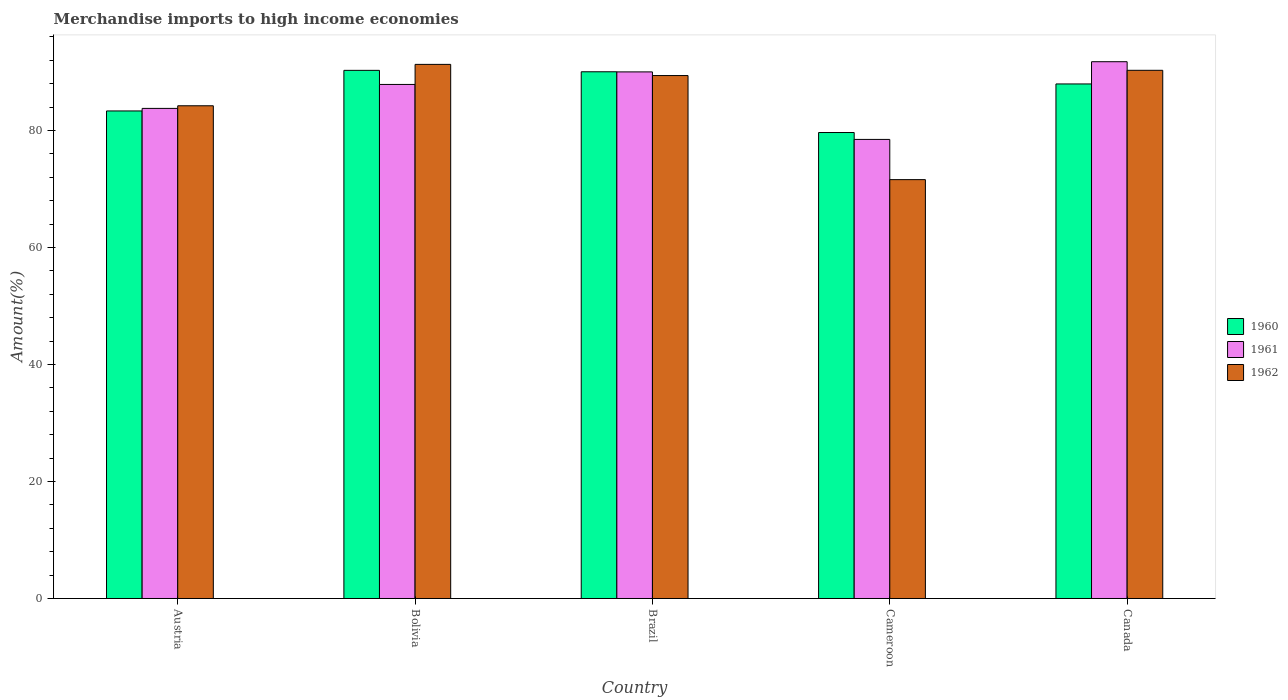How many different coloured bars are there?
Make the answer very short. 3. Are the number of bars per tick equal to the number of legend labels?
Provide a short and direct response. Yes. Are the number of bars on each tick of the X-axis equal?
Your answer should be compact. Yes. In how many cases, is the number of bars for a given country not equal to the number of legend labels?
Ensure brevity in your answer.  0. What is the percentage of amount earned from merchandise imports in 1961 in Bolivia?
Your answer should be very brief. 87.89. Across all countries, what is the maximum percentage of amount earned from merchandise imports in 1962?
Ensure brevity in your answer.  91.32. Across all countries, what is the minimum percentage of amount earned from merchandise imports in 1960?
Offer a terse response. 79.67. In which country was the percentage of amount earned from merchandise imports in 1960 minimum?
Give a very brief answer. Cameroon. What is the total percentage of amount earned from merchandise imports in 1961 in the graph?
Offer a terse response. 431.97. What is the difference between the percentage of amount earned from merchandise imports in 1960 in Brazil and that in Canada?
Provide a succinct answer. 2.08. What is the difference between the percentage of amount earned from merchandise imports in 1961 in Bolivia and the percentage of amount earned from merchandise imports in 1960 in Cameroon?
Make the answer very short. 8.22. What is the average percentage of amount earned from merchandise imports in 1960 per country?
Offer a terse response. 86.27. What is the difference between the percentage of amount earned from merchandise imports of/in 1960 and percentage of amount earned from merchandise imports of/in 1962 in Bolivia?
Provide a short and direct response. -1.02. In how many countries, is the percentage of amount earned from merchandise imports in 1962 greater than 12 %?
Offer a terse response. 5. What is the ratio of the percentage of amount earned from merchandise imports in 1960 in Bolivia to that in Canada?
Keep it short and to the point. 1.03. Is the percentage of amount earned from merchandise imports in 1962 in Bolivia less than that in Canada?
Your answer should be compact. No. Is the difference between the percentage of amount earned from merchandise imports in 1960 in Bolivia and Canada greater than the difference between the percentage of amount earned from merchandise imports in 1962 in Bolivia and Canada?
Your answer should be very brief. Yes. What is the difference between the highest and the second highest percentage of amount earned from merchandise imports in 1962?
Provide a succinct answer. -0.9. What is the difference between the highest and the lowest percentage of amount earned from merchandise imports in 1961?
Your answer should be very brief. 13.28. What does the 1st bar from the left in Austria represents?
Your answer should be compact. 1960. How many bars are there?
Offer a very short reply. 15. Are all the bars in the graph horizontal?
Your answer should be compact. No. Are the values on the major ticks of Y-axis written in scientific E-notation?
Provide a short and direct response. No. Does the graph contain any zero values?
Offer a very short reply. No. Where does the legend appear in the graph?
Keep it short and to the point. Center right. What is the title of the graph?
Offer a very short reply. Merchandise imports to high income economies. What is the label or title of the Y-axis?
Provide a succinct answer. Amount(%). What is the Amount(%) of 1960 in Austria?
Give a very brief answer. 83.35. What is the Amount(%) in 1961 in Austria?
Your answer should be compact. 83.79. What is the Amount(%) in 1962 in Austria?
Give a very brief answer. 84.24. What is the Amount(%) in 1960 in Bolivia?
Your answer should be compact. 90.3. What is the Amount(%) in 1961 in Bolivia?
Your response must be concise. 87.89. What is the Amount(%) in 1962 in Bolivia?
Offer a terse response. 91.32. What is the Amount(%) in 1960 in Brazil?
Your response must be concise. 90.05. What is the Amount(%) of 1961 in Brazil?
Provide a succinct answer. 90.03. What is the Amount(%) of 1962 in Brazil?
Keep it short and to the point. 89.41. What is the Amount(%) of 1960 in Cameroon?
Make the answer very short. 79.67. What is the Amount(%) of 1961 in Cameroon?
Offer a very short reply. 78.49. What is the Amount(%) in 1962 in Cameroon?
Keep it short and to the point. 71.61. What is the Amount(%) in 1960 in Canada?
Make the answer very short. 87.97. What is the Amount(%) in 1961 in Canada?
Your answer should be compact. 91.77. What is the Amount(%) in 1962 in Canada?
Offer a terse response. 90.3. Across all countries, what is the maximum Amount(%) in 1960?
Provide a succinct answer. 90.3. Across all countries, what is the maximum Amount(%) in 1961?
Keep it short and to the point. 91.77. Across all countries, what is the maximum Amount(%) of 1962?
Keep it short and to the point. 91.32. Across all countries, what is the minimum Amount(%) in 1960?
Offer a terse response. 79.67. Across all countries, what is the minimum Amount(%) in 1961?
Provide a short and direct response. 78.49. Across all countries, what is the minimum Amount(%) in 1962?
Offer a terse response. 71.61. What is the total Amount(%) in 1960 in the graph?
Give a very brief answer. 431.34. What is the total Amount(%) in 1961 in the graph?
Offer a terse response. 431.97. What is the total Amount(%) of 1962 in the graph?
Your response must be concise. 426.88. What is the difference between the Amount(%) in 1960 in Austria and that in Bolivia?
Provide a short and direct response. -6.94. What is the difference between the Amount(%) of 1961 in Austria and that in Bolivia?
Ensure brevity in your answer.  -4.1. What is the difference between the Amount(%) of 1962 in Austria and that in Bolivia?
Offer a very short reply. -7.08. What is the difference between the Amount(%) of 1960 in Austria and that in Brazil?
Offer a very short reply. -6.7. What is the difference between the Amount(%) of 1961 in Austria and that in Brazil?
Offer a very short reply. -6.24. What is the difference between the Amount(%) of 1962 in Austria and that in Brazil?
Provide a short and direct response. -5.17. What is the difference between the Amount(%) of 1960 in Austria and that in Cameroon?
Offer a terse response. 3.69. What is the difference between the Amount(%) of 1961 in Austria and that in Cameroon?
Give a very brief answer. 5.3. What is the difference between the Amount(%) of 1962 in Austria and that in Cameroon?
Give a very brief answer. 12.63. What is the difference between the Amount(%) in 1960 in Austria and that in Canada?
Offer a terse response. -4.62. What is the difference between the Amount(%) of 1961 in Austria and that in Canada?
Ensure brevity in your answer.  -7.98. What is the difference between the Amount(%) of 1962 in Austria and that in Canada?
Provide a short and direct response. -6.06. What is the difference between the Amount(%) in 1960 in Bolivia and that in Brazil?
Make the answer very short. 0.24. What is the difference between the Amount(%) in 1961 in Bolivia and that in Brazil?
Offer a terse response. -2.14. What is the difference between the Amount(%) of 1962 in Bolivia and that in Brazil?
Your response must be concise. 1.91. What is the difference between the Amount(%) in 1960 in Bolivia and that in Cameroon?
Offer a very short reply. 10.63. What is the difference between the Amount(%) in 1961 in Bolivia and that in Cameroon?
Offer a very short reply. 9.4. What is the difference between the Amount(%) of 1962 in Bolivia and that in Cameroon?
Keep it short and to the point. 19.71. What is the difference between the Amount(%) of 1960 in Bolivia and that in Canada?
Ensure brevity in your answer.  2.32. What is the difference between the Amount(%) in 1961 in Bolivia and that in Canada?
Your answer should be compact. -3.89. What is the difference between the Amount(%) of 1962 in Bolivia and that in Canada?
Give a very brief answer. 1.01. What is the difference between the Amount(%) of 1960 in Brazil and that in Cameroon?
Your response must be concise. 10.38. What is the difference between the Amount(%) of 1961 in Brazil and that in Cameroon?
Your answer should be very brief. 11.54. What is the difference between the Amount(%) in 1962 in Brazil and that in Cameroon?
Offer a terse response. 17.8. What is the difference between the Amount(%) of 1960 in Brazil and that in Canada?
Give a very brief answer. 2.08. What is the difference between the Amount(%) in 1961 in Brazil and that in Canada?
Provide a succinct answer. -1.74. What is the difference between the Amount(%) of 1962 in Brazil and that in Canada?
Your answer should be very brief. -0.9. What is the difference between the Amount(%) of 1960 in Cameroon and that in Canada?
Offer a terse response. -8.31. What is the difference between the Amount(%) in 1961 in Cameroon and that in Canada?
Give a very brief answer. -13.28. What is the difference between the Amount(%) of 1962 in Cameroon and that in Canada?
Provide a succinct answer. -18.69. What is the difference between the Amount(%) in 1960 in Austria and the Amount(%) in 1961 in Bolivia?
Provide a short and direct response. -4.53. What is the difference between the Amount(%) of 1960 in Austria and the Amount(%) of 1962 in Bolivia?
Your response must be concise. -7.96. What is the difference between the Amount(%) of 1961 in Austria and the Amount(%) of 1962 in Bolivia?
Keep it short and to the point. -7.53. What is the difference between the Amount(%) in 1960 in Austria and the Amount(%) in 1961 in Brazil?
Your response must be concise. -6.68. What is the difference between the Amount(%) in 1960 in Austria and the Amount(%) in 1962 in Brazil?
Your answer should be very brief. -6.05. What is the difference between the Amount(%) of 1961 in Austria and the Amount(%) of 1962 in Brazil?
Provide a succinct answer. -5.62. What is the difference between the Amount(%) in 1960 in Austria and the Amount(%) in 1961 in Cameroon?
Offer a terse response. 4.87. What is the difference between the Amount(%) in 1960 in Austria and the Amount(%) in 1962 in Cameroon?
Make the answer very short. 11.74. What is the difference between the Amount(%) of 1961 in Austria and the Amount(%) of 1962 in Cameroon?
Your answer should be very brief. 12.18. What is the difference between the Amount(%) of 1960 in Austria and the Amount(%) of 1961 in Canada?
Your answer should be compact. -8.42. What is the difference between the Amount(%) in 1960 in Austria and the Amount(%) in 1962 in Canada?
Provide a succinct answer. -6.95. What is the difference between the Amount(%) of 1961 in Austria and the Amount(%) of 1962 in Canada?
Offer a very short reply. -6.51. What is the difference between the Amount(%) in 1960 in Bolivia and the Amount(%) in 1961 in Brazil?
Your answer should be very brief. 0.26. What is the difference between the Amount(%) of 1960 in Bolivia and the Amount(%) of 1962 in Brazil?
Your response must be concise. 0.89. What is the difference between the Amount(%) of 1961 in Bolivia and the Amount(%) of 1962 in Brazil?
Keep it short and to the point. -1.52. What is the difference between the Amount(%) of 1960 in Bolivia and the Amount(%) of 1961 in Cameroon?
Make the answer very short. 11.81. What is the difference between the Amount(%) of 1960 in Bolivia and the Amount(%) of 1962 in Cameroon?
Offer a terse response. 18.68. What is the difference between the Amount(%) of 1961 in Bolivia and the Amount(%) of 1962 in Cameroon?
Your response must be concise. 16.28. What is the difference between the Amount(%) in 1960 in Bolivia and the Amount(%) in 1961 in Canada?
Offer a very short reply. -1.48. What is the difference between the Amount(%) in 1960 in Bolivia and the Amount(%) in 1962 in Canada?
Offer a terse response. -0.01. What is the difference between the Amount(%) in 1961 in Bolivia and the Amount(%) in 1962 in Canada?
Provide a succinct answer. -2.42. What is the difference between the Amount(%) in 1960 in Brazil and the Amount(%) in 1961 in Cameroon?
Your answer should be very brief. 11.56. What is the difference between the Amount(%) in 1960 in Brazil and the Amount(%) in 1962 in Cameroon?
Your answer should be very brief. 18.44. What is the difference between the Amount(%) of 1961 in Brazil and the Amount(%) of 1962 in Cameroon?
Ensure brevity in your answer.  18.42. What is the difference between the Amount(%) in 1960 in Brazil and the Amount(%) in 1961 in Canada?
Provide a short and direct response. -1.72. What is the difference between the Amount(%) of 1960 in Brazil and the Amount(%) of 1962 in Canada?
Provide a short and direct response. -0.25. What is the difference between the Amount(%) of 1961 in Brazil and the Amount(%) of 1962 in Canada?
Your answer should be very brief. -0.27. What is the difference between the Amount(%) in 1960 in Cameroon and the Amount(%) in 1961 in Canada?
Provide a short and direct response. -12.11. What is the difference between the Amount(%) in 1960 in Cameroon and the Amount(%) in 1962 in Canada?
Offer a terse response. -10.64. What is the difference between the Amount(%) in 1961 in Cameroon and the Amount(%) in 1962 in Canada?
Make the answer very short. -11.82. What is the average Amount(%) of 1960 per country?
Ensure brevity in your answer.  86.27. What is the average Amount(%) of 1961 per country?
Give a very brief answer. 86.39. What is the average Amount(%) of 1962 per country?
Keep it short and to the point. 85.38. What is the difference between the Amount(%) of 1960 and Amount(%) of 1961 in Austria?
Your answer should be compact. -0.44. What is the difference between the Amount(%) of 1960 and Amount(%) of 1962 in Austria?
Your answer should be very brief. -0.89. What is the difference between the Amount(%) of 1961 and Amount(%) of 1962 in Austria?
Your response must be concise. -0.45. What is the difference between the Amount(%) in 1960 and Amount(%) in 1961 in Bolivia?
Give a very brief answer. 2.41. What is the difference between the Amount(%) of 1960 and Amount(%) of 1962 in Bolivia?
Offer a very short reply. -1.02. What is the difference between the Amount(%) of 1961 and Amount(%) of 1962 in Bolivia?
Your response must be concise. -3.43. What is the difference between the Amount(%) of 1960 and Amount(%) of 1961 in Brazil?
Give a very brief answer. 0.02. What is the difference between the Amount(%) of 1960 and Amount(%) of 1962 in Brazil?
Make the answer very short. 0.64. What is the difference between the Amount(%) of 1961 and Amount(%) of 1962 in Brazil?
Your answer should be very brief. 0.62. What is the difference between the Amount(%) in 1960 and Amount(%) in 1961 in Cameroon?
Provide a succinct answer. 1.18. What is the difference between the Amount(%) of 1960 and Amount(%) of 1962 in Cameroon?
Give a very brief answer. 8.06. What is the difference between the Amount(%) in 1961 and Amount(%) in 1962 in Cameroon?
Offer a terse response. 6.88. What is the difference between the Amount(%) of 1960 and Amount(%) of 1961 in Canada?
Keep it short and to the point. -3.8. What is the difference between the Amount(%) of 1960 and Amount(%) of 1962 in Canada?
Keep it short and to the point. -2.33. What is the difference between the Amount(%) of 1961 and Amount(%) of 1962 in Canada?
Ensure brevity in your answer.  1.47. What is the ratio of the Amount(%) in 1960 in Austria to that in Bolivia?
Offer a very short reply. 0.92. What is the ratio of the Amount(%) of 1961 in Austria to that in Bolivia?
Ensure brevity in your answer.  0.95. What is the ratio of the Amount(%) of 1962 in Austria to that in Bolivia?
Offer a terse response. 0.92. What is the ratio of the Amount(%) in 1960 in Austria to that in Brazil?
Make the answer very short. 0.93. What is the ratio of the Amount(%) in 1961 in Austria to that in Brazil?
Your answer should be very brief. 0.93. What is the ratio of the Amount(%) in 1962 in Austria to that in Brazil?
Give a very brief answer. 0.94. What is the ratio of the Amount(%) in 1960 in Austria to that in Cameroon?
Provide a succinct answer. 1.05. What is the ratio of the Amount(%) in 1961 in Austria to that in Cameroon?
Keep it short and to the point. 1.07. What is the ratio of the Amount(%) of 1962 in Austria to that in Cameroon?
Offer a very short reply. 1.18. What is the ratio of the Amount(%) in 1960 in Austria to that in Canada?
Ensure brevity in your answer.  0.95. What is the ratio of the Amount(%) in 1961 in Austria to that in Canada?
Give a very brief answer. 0.91. What is the ratio of the Amount(%) in 1962 in Austria to that in Canada?
Keep it short and to the point. 0.93. What is the ratio of the Amount(%) of 1960 in Bolivia to that in Brazil?
Your answer should be very brief. 1. What is the ratio of the Amount(%) in 1961 in Bolivia to that in Brazil?
Provide a succinct answer. 0.98. What is the ratio of the Amount(%) in 1962 in Bolivia to that in Brazil?
Your response must be concise. 1.02. What is the ratio of the Amount(%) in 1960 in Bolivia to that in Cameroon?
Keep it short and to the point. 1.13. What is the ratio of the Amount(%) in 1961 in Bolivia to that in Cameroon?
Give a very brief answer. 1.12. What is the ratio of the Amount(%) in 1962 in Bolivia to that in Cameroon?
Give a very brief answer. 1.28. What is the ratio of the Amount(%) in 1960 in Bolivia to that in Canada?
Give a very brief answer. 1.03. What is the ratio of the Amount(%) of 1961 in Bolivia to that in Canada?
Offer a terse response. 0.96. What is the ratio of the Amount(%) in 1962 in Bolivia to that in Canada?
Offer a terse response. 1.01. What is the ratio of the Amount(%) of 1960 in Brazil to that in Cameroon?
Your answer should be very brief. 1.13. What is the ratio of the Amount(%) in 1961 in Brazil to that in Cameroon?
Your answer should be very brief. 1.15. What is the ratio of the Amount(%) of 1962 in Brazil to that in Cameroon?
Your answer should be very brief. 1.25. What is the ratio of the Amount(%) in 1960 in Brazil to that in Canada?
Give a very brief answer. 1.02. What is the ratio of the Amount(%) of 1961 in Brazil to that in Canada?
Your answer should be very brief. 0.98. What is the ratio of the Amount(%) of 1962 in Brazil to that in Canada?
Offer a very short reply. 0.99. What is the ratio of the Amount(%) in 1960 in Cameroon to that in Canada?
Provide a short and direct response. 0.91. What is the ratio of the Amount(%) in 1961 in Cameroon to that in Canada?
Your answer should be compact. 0.86. What is the ratio of the Amount(%) of 1962 in Cameroon to that in Canada?
Make the answer very short. 0.79. What is the difference between the highest and the second highest Amount(%) of 1960?
Give a very brief answer. 0.24. What is the difference between the highest and the second highest Amount(%) in 1961?
Ensure brevity in your answer.  1.74. What is the difference between the highest and the second highest Amount(%) in 1962?
Offer a terse response. 1.01. What is the difference between the highest and the lowest Amount(%) in 1960?
Provide a short and direct response. 10.63. What is the difference between the highest and the lowest Amount(%) in 1961?
Ensure brevity in your answer.  13.28. What is the difference between the highest and the lowest Amount(%) of 1962?
Your response must be concise. 19.71. 